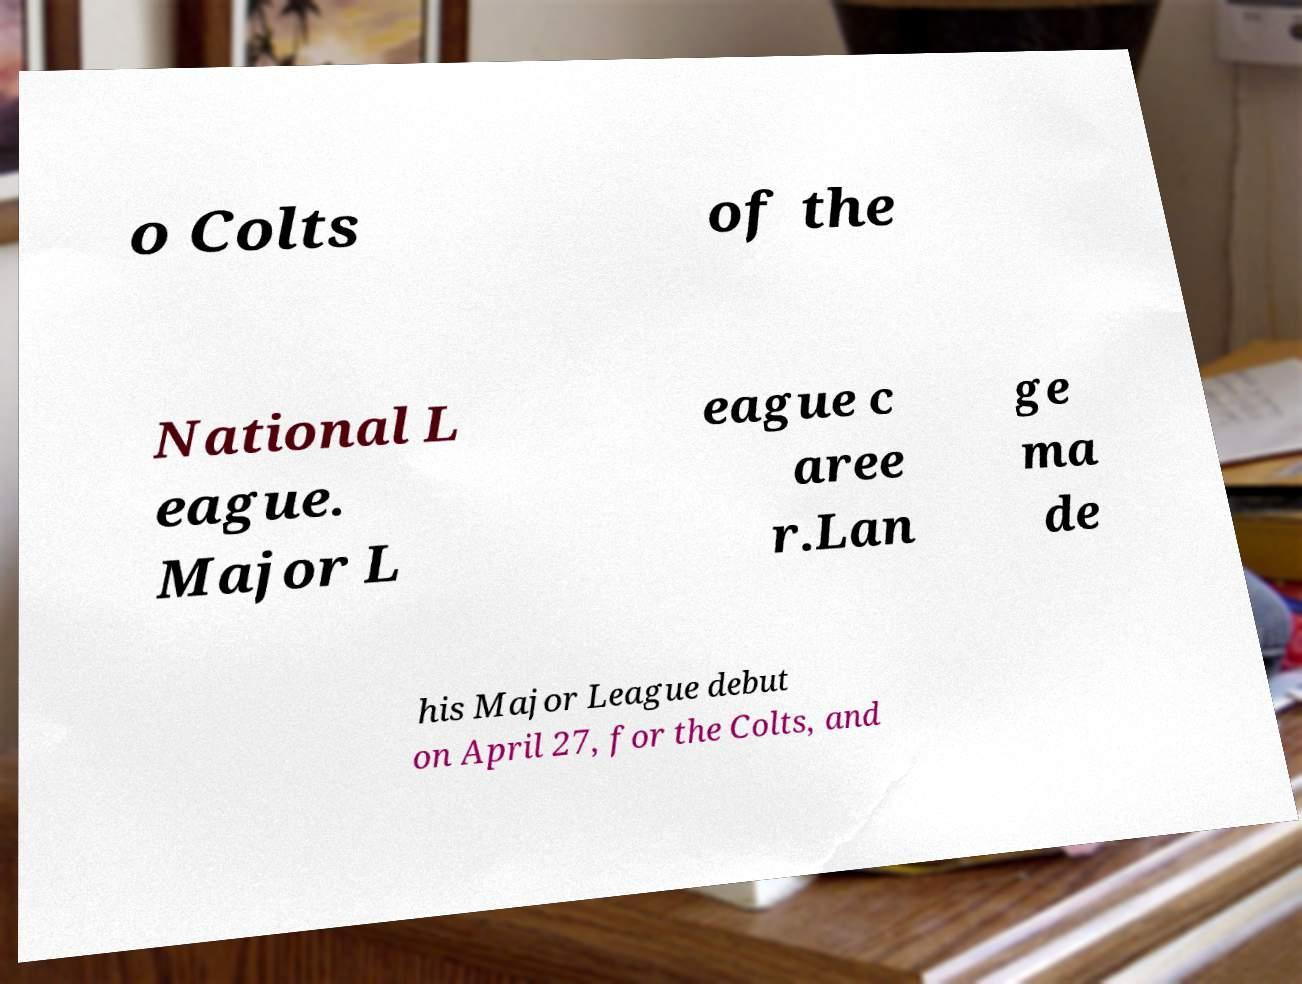There's text embedded in this image that I need extracted. Can you transcribe it verbatim? o Colts of the National L eague. Major L eague c aree r.Lan ge ma de his Major League debut on April 27, for the Colts, and 